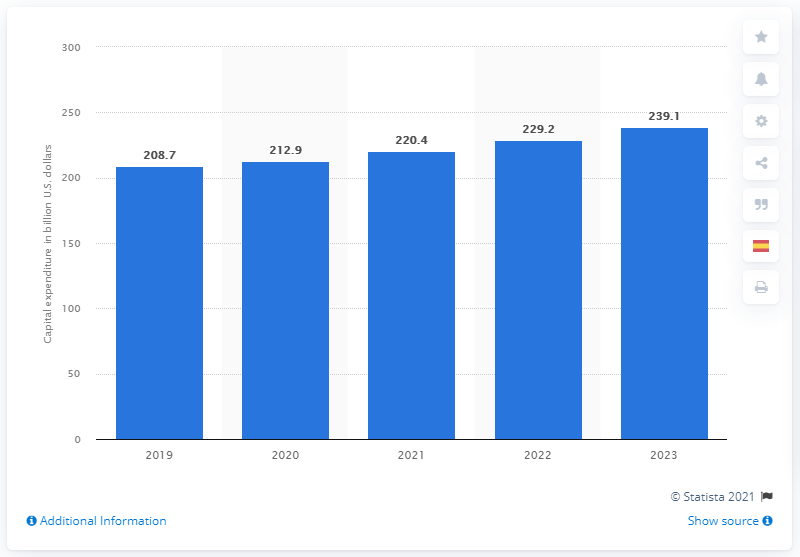Mention a couple of crucial points in this snapshot. The global capital expenditure in the chemical industry is expected to reach 239.1 billion U.S. dollars in 2023, according to a recent report. 